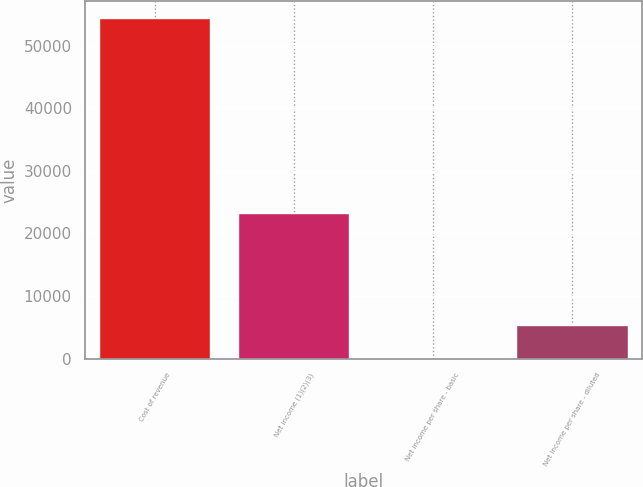Convert chart. <chart><loc_0><loc_0><loc_500><loc_500><bar_chart><fcel>Cost of revenue<fcel>Net income (1)(2)(3)<fcel>Net income per share - basic<fcel>Net income per share - diluted<nl><fcel>54413<fcel>23263<fcel>0.08<fcel>5441.37<nl></chart> 